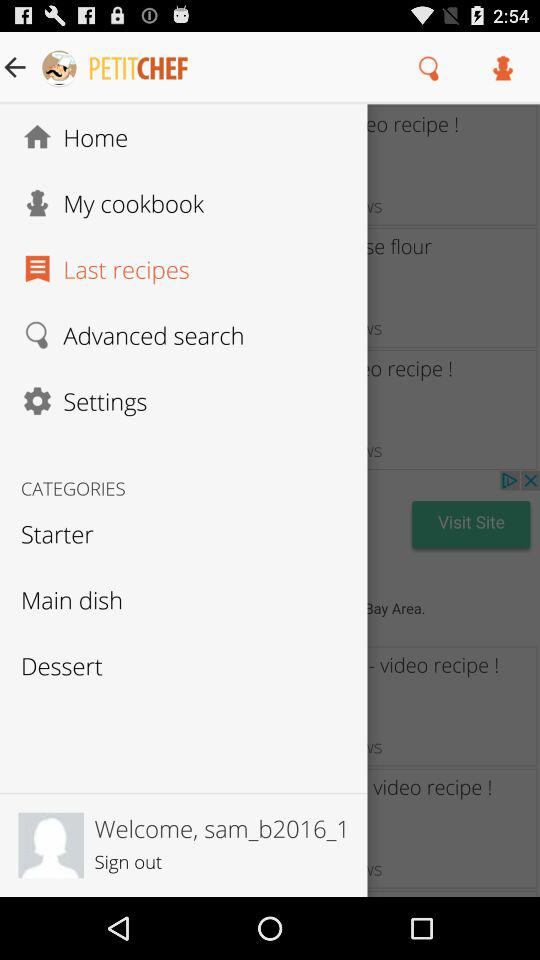What is the user's name? The user's name is sam_b2016_1. 